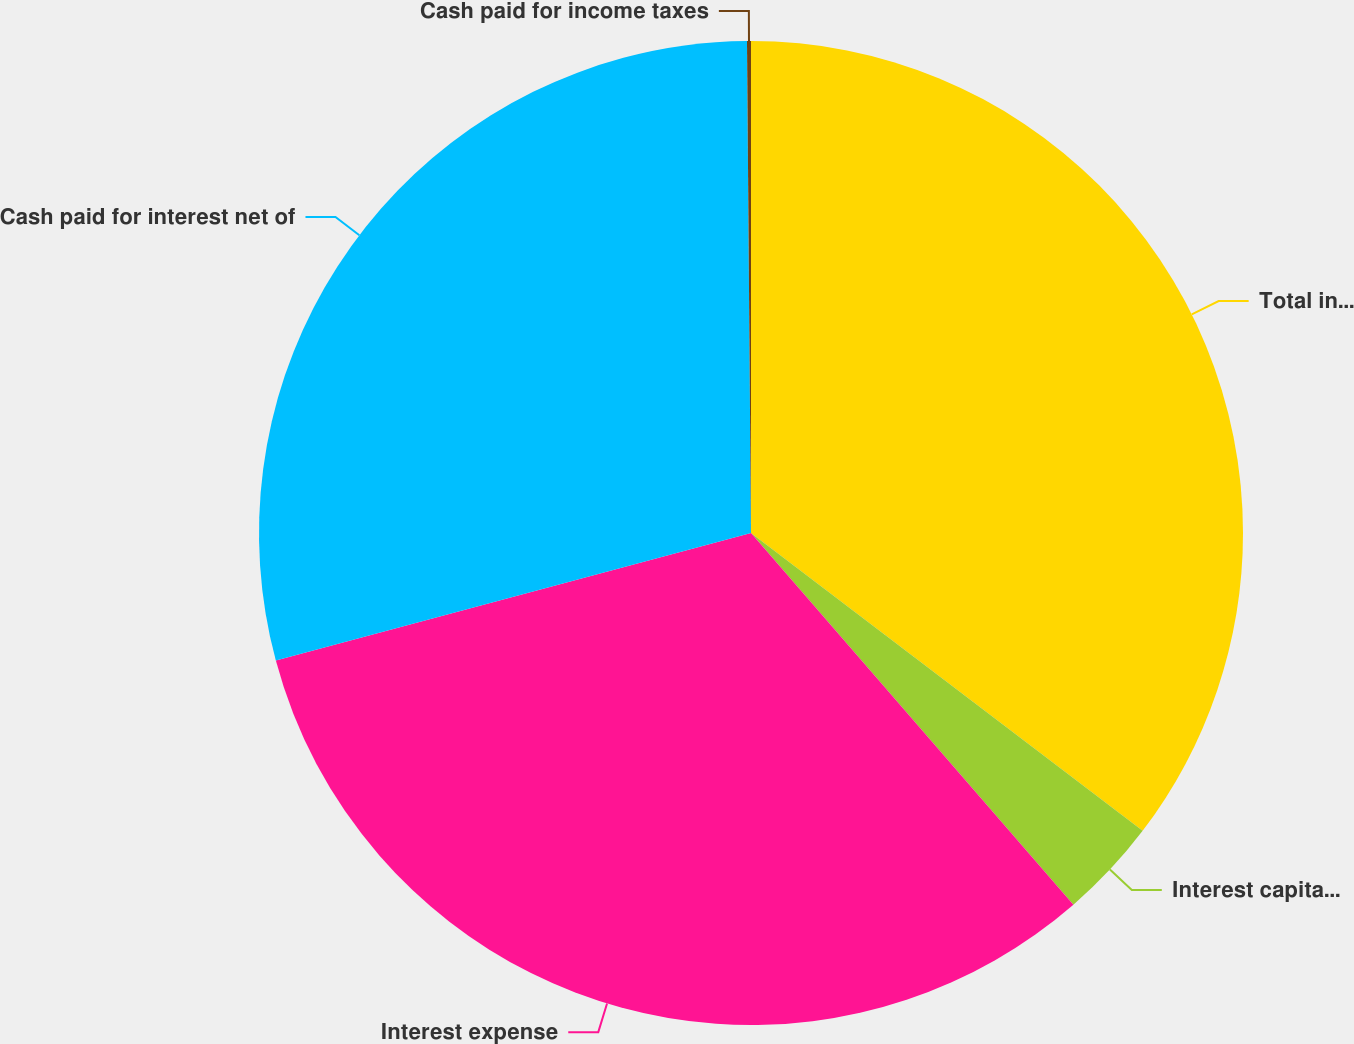<chart> <loc_0><loc_0><loc_500><loc_500><pie_chart><fcel>Total interest costs incurred<fcel>Interest capitalized<fcel>Interest expense<fcel>Cash paid for interest net of<fcel>Cash paid for income taxes<nl><fcel>35.34%<fcel>3.28%<fcel>32.19%<fcel>29.04%<fcel>0.13%<nl></chart> 